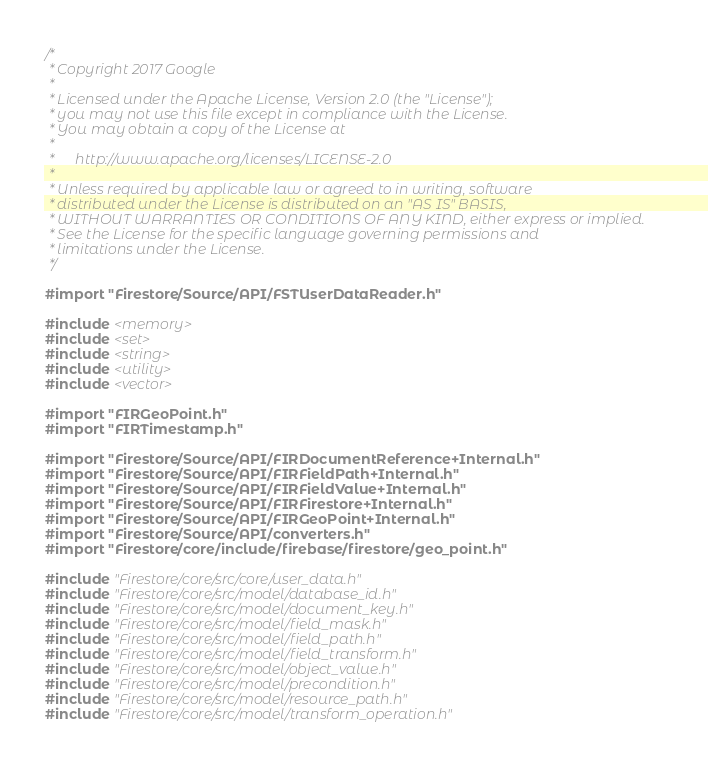Convert code to text. <code><loc_0><loc_0><loc_500><loc_500><_ObjectiveC_>/*
 * Copyright 2017 Google
 *
 * Licensed under the Apache License, Version 2.0 (the "License");
 * you may not use this file except in compliance with the License.
 * You may obtain a copy of the License at
 *
 *      http://www.apache.org/licenses/LICENSE-2.0
 *
 * Unless required by applicable law or agreed to in writing, software
 * distributed under the License is distributed on an "AS IS" BASIS,
 * WITHOUT WARRANTIES OR CONDITIONS OF ANY KIND, either express or implied.
 * See the License for the specific language governing permissions and
 * limitations under the License.
 */

#import "Firestore/Source/API/FSTUserDataReader.h"

#include <memory>
#include <set>
#include <string>
#include <utility>
#include <vector>

#import "FIRGeoPoint.h"
#import "FIRTimestamp.h"

#import "Firestore/Source/API/FIRDocumentReference+Internal.h"
#import "Firestore/Source/API/FIRFieldPath+Internal.h"
#import "Firestore/Source/API/FIRFieldValue+Internal.h"
#import "Firestore/Source/API/FIRFirestore+Internal.h"
#import "Firestore/Source/API/FIRGeoPoint+Internal.h"
#import "Firestore/Source/API/converters.h"
#import "Firestore/core/include/firebase/firestore/geo_point.h"

#include "Firestore/core/src/core/user_data.h"
#include "Firestore/core/src/model/database_id.h"
#include "Firestore/core/src/model/document_key.h"
#include "Firestore/core/src/model/field_mask.h"
#include "Firestore/core/src/model/field_path.h"
#include "Firestore/core/src/model/field_transform.h"
#include "Firestore/core/src/model/object_value.h"
#include "Firestore/core/src/model/precondition.h"
#include "Firestore/core/src/model/resource_path.h"
#include "Firestore/core/src/model/transform_operation.h"</code> 